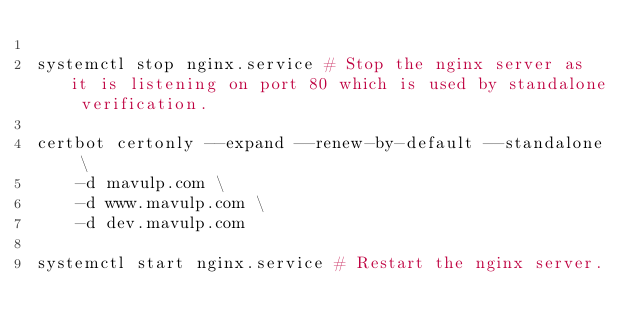<code> <loc_0><loc_0><loc_500><loc_500><_Bash_>
systemctl stop nginx.service # Stop the nginx server as it is listening on port 80 which is used by standalone verification.

certbot certonly --expand --renew-by-default --standalone \
	-d mavulp.com \
	-d www.mavulp.com \
	-d dev.mavulp.com

systemctl start nginx.service # Restart the nginx server.

</code> 